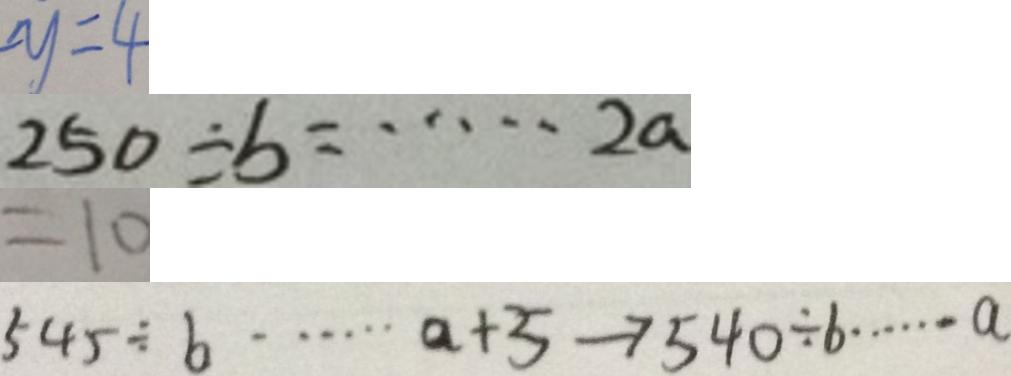Convert formula to latex. <formula><loc_0><loc_0><loc_500><loc_500>- y = 4 
 2 5 0 \div b = \cdots 2 a 
 = 1 0 
 5 4 5 \div b \cdots a + 5 \rightarrow 5 4 0 \div b \cdots a</formula> 